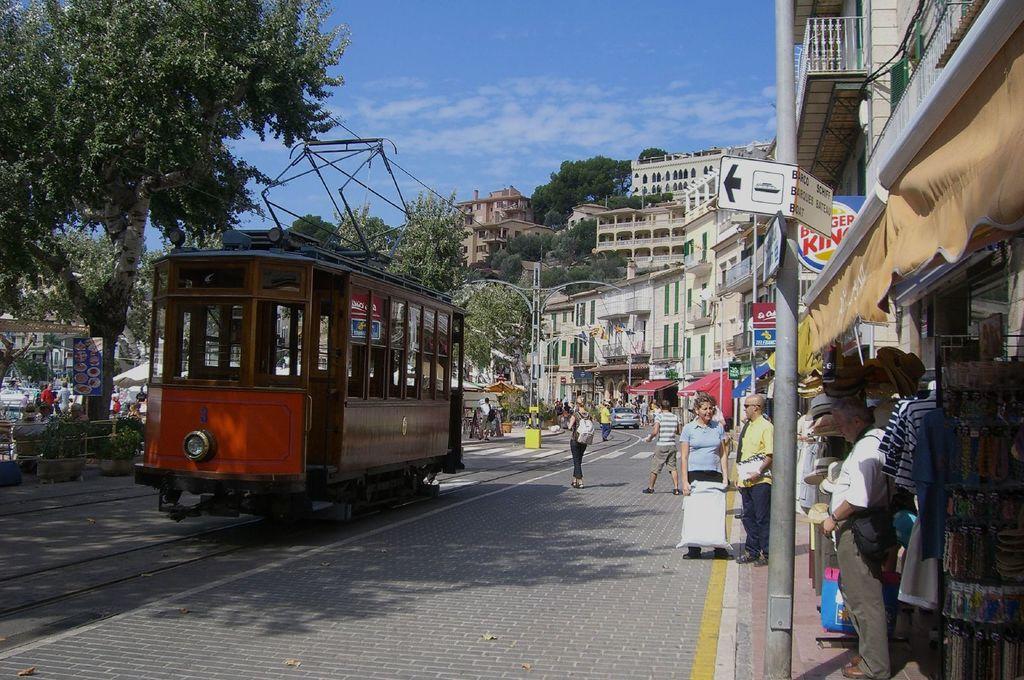What is the name of the fast food restaurant?
Make the answer very short. Burger king. 